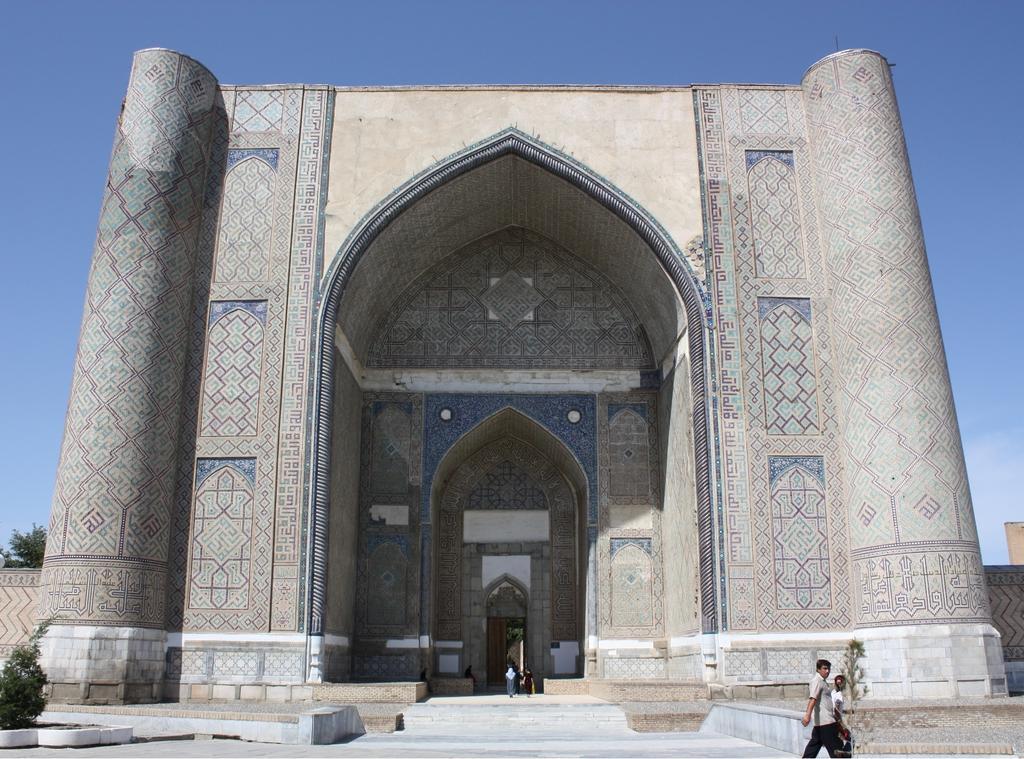Can you describe this image briefly? In this image I can see monument ,in front of the moment I can see there are two persons walking ,at the top I can see the sky, on the left side I can see plants. 